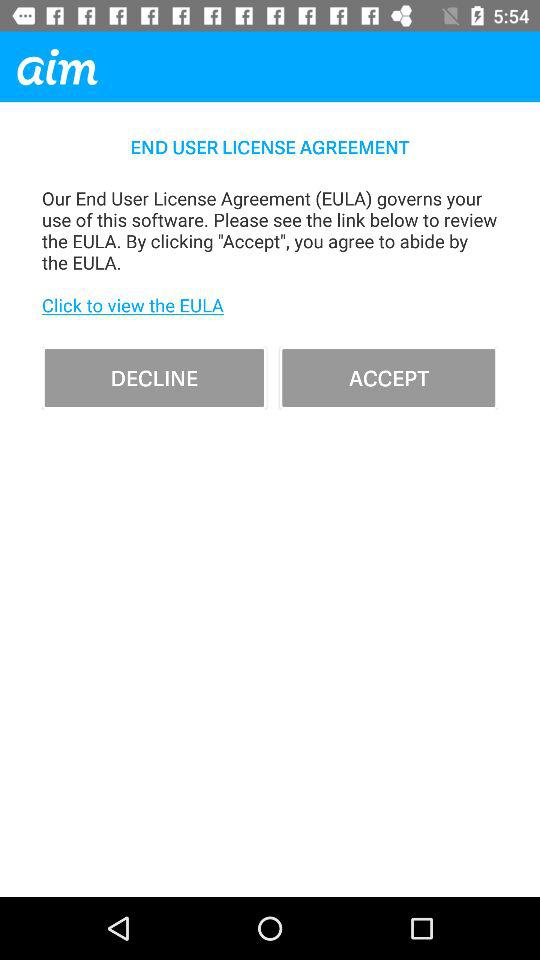What is the name of the application? The name of the application is "aim". 